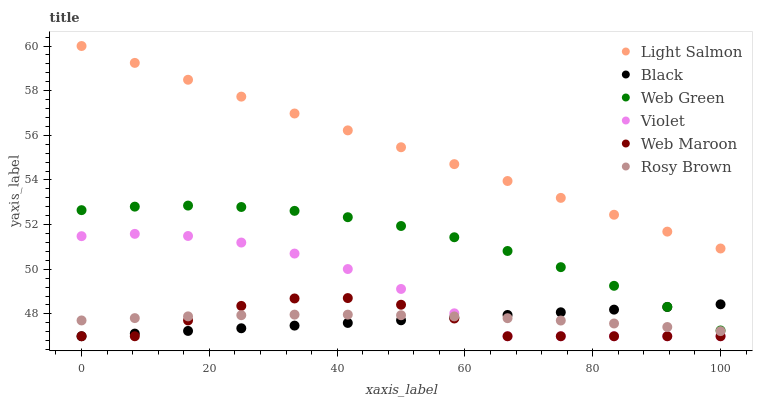Does Web Maroon have the minimum area under the curve?
Answer yes or no. Yes. Does Light Salmon have the maximum area under the curve?
Answer yes or no. Yes. Does Rosy Brown have the minimum area under the curve?
Answer yes or no. No. Does Rosy Brown have the maximum area under the curve?
Answer yes or no. No. Is Light Salmon the smoothest?
Answer yes or no. Yes. Is Web Maroon the roughest?
Answer yes or no. Yes. Is Rosy Brown the smoothest?
Answer yes or no. No. Is Rosy Brown the roughest?
Answer yes or no. No. Does Web Maroon have the lowest value?
Answer yes or no. Yes. Does Rosy Brown have the lowest value?
Answer yes or no. No. Does Light Salmon have the highest value?
Answer yes or no. Yes. Does Web Maroon have the highest value?
Answer yes or no. No. Is Rosy Brown less than Web Green?
Answer yes or no. Yes. Is Light Salmon greater than Web Green?
Answer yes or no. Yes. Does Rosy Brown intersect Black?
Answer yes or no. Yes. Is Rosy Brown less than Black?
Answer yes or no. No. Is Rosy Brown greater than Black?
Answer yes or no. No. Does Rosy Brown intersect Web Green?
Answer yes or no. No. 